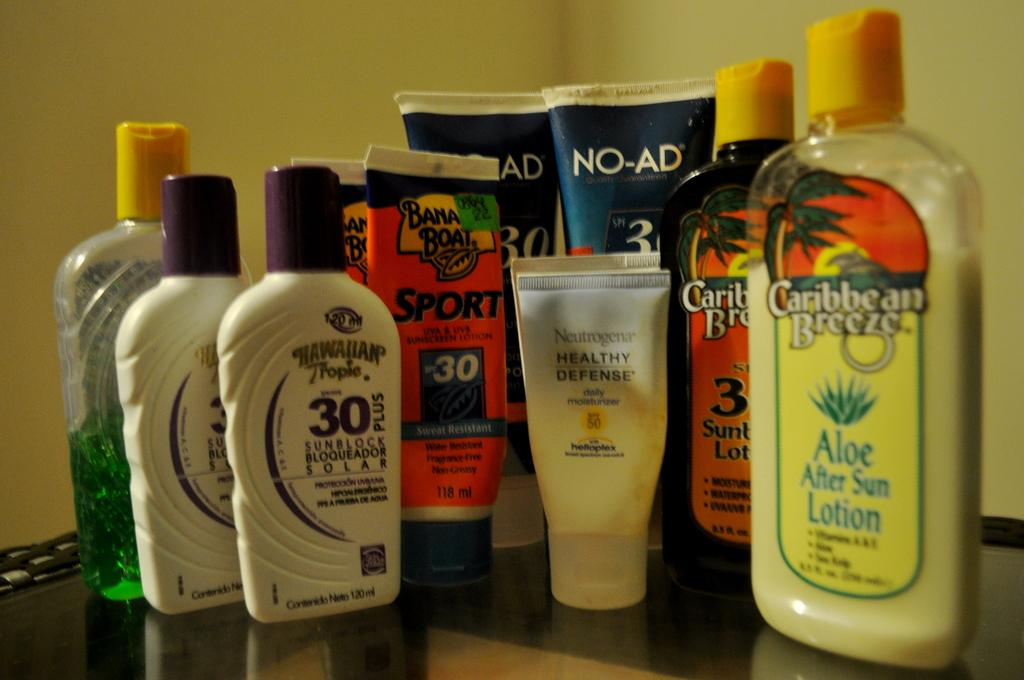What is located at the bottom of the image? There is a table at the bottom of the image. What objects are on the table? There are bottles on the table. What is visible behind the table? There is a wall behind the table. What type of ring can be seen on the wall in the image? There is no ring present on the wall in the image. What is the health status of the bottles on the table? The health status of the bottles cannot be determined from the image, as it only shows their physical appearance. 